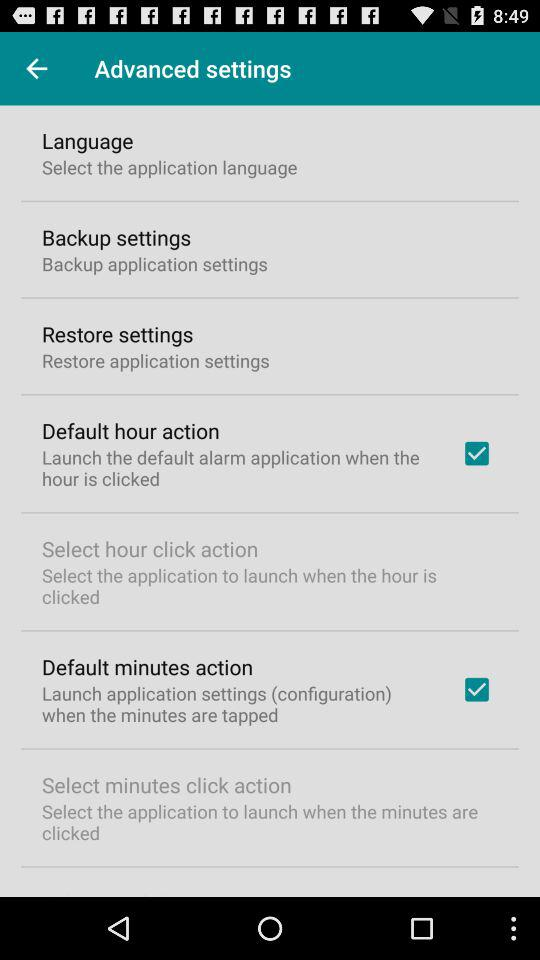What is the status of "Default hour action"? The status of "Default hour action" is "on". 